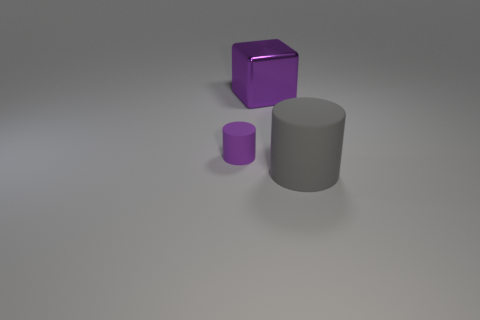Are there any other things of the same color as the metallic block?
Your answer should be compact. Yes. There is a big metal thing; is its shape the same as the small purple object in front of the metal thing?
Offer a terse response. No. What is the color of the object in front of the cylinder that is on the left side of the object on the right side of the purple shiny object?
Offer a very short reply. Gray. Is there anything else that is the same material as the large cube?
Provide a short and direct response. No. There is a thing that is on the right side of the purple block; is it the same shape as the tiny rubber thing?
Offer a terse response. Yes. What material is the large cylinder?
Your response must be concise. Rubber. What shape is the large object that is left of the matte object that is in front of the rubber cylinder that is on the left side of the big matte cylinder?
Your answer should be very brief. Cube. What number of other objects are there of the same shape as the large matte thing?
Your response must be concise. 1. There is a cube; does it have the same color as the object to the left of the purple block?
Ensure brevity in your answer.  Yes. How many tiny blue objects are there?
Offer a very short reply. 0. 